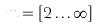<formula> <loc_0><loc_0><loc_500><loc_500>m = [ 2 \dots \infty ]</formula> 